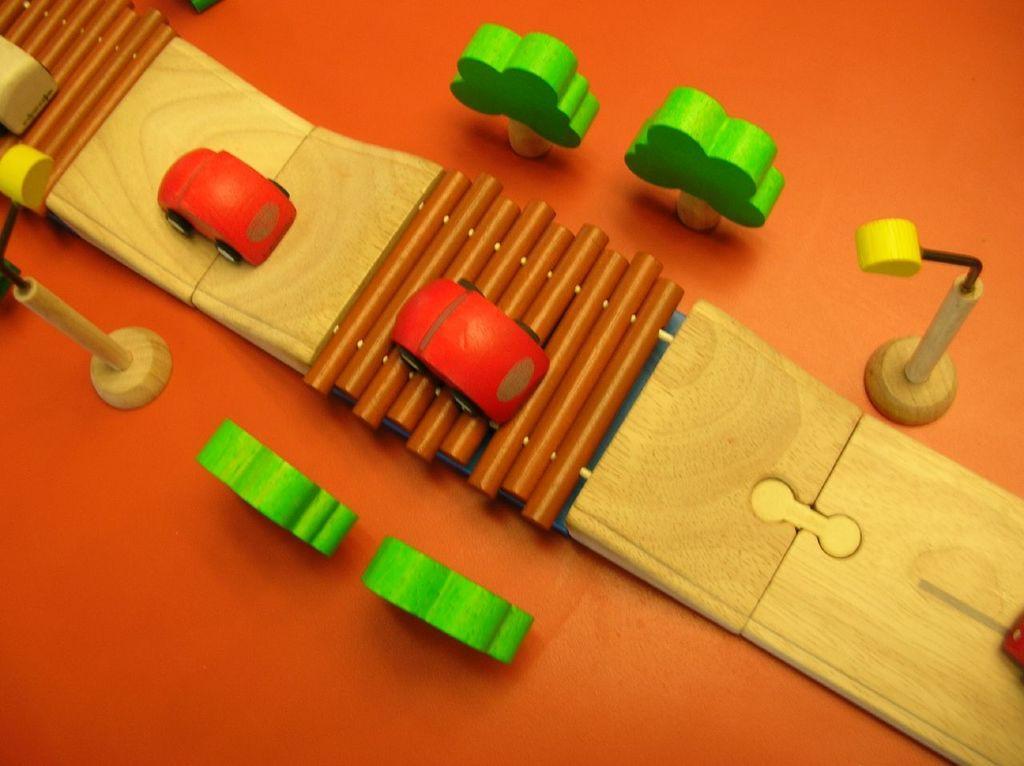In one or two sentences, can you explain what this image depicts? In this image in the center there are some toys and a wooden board, at the bottom there is a table. 